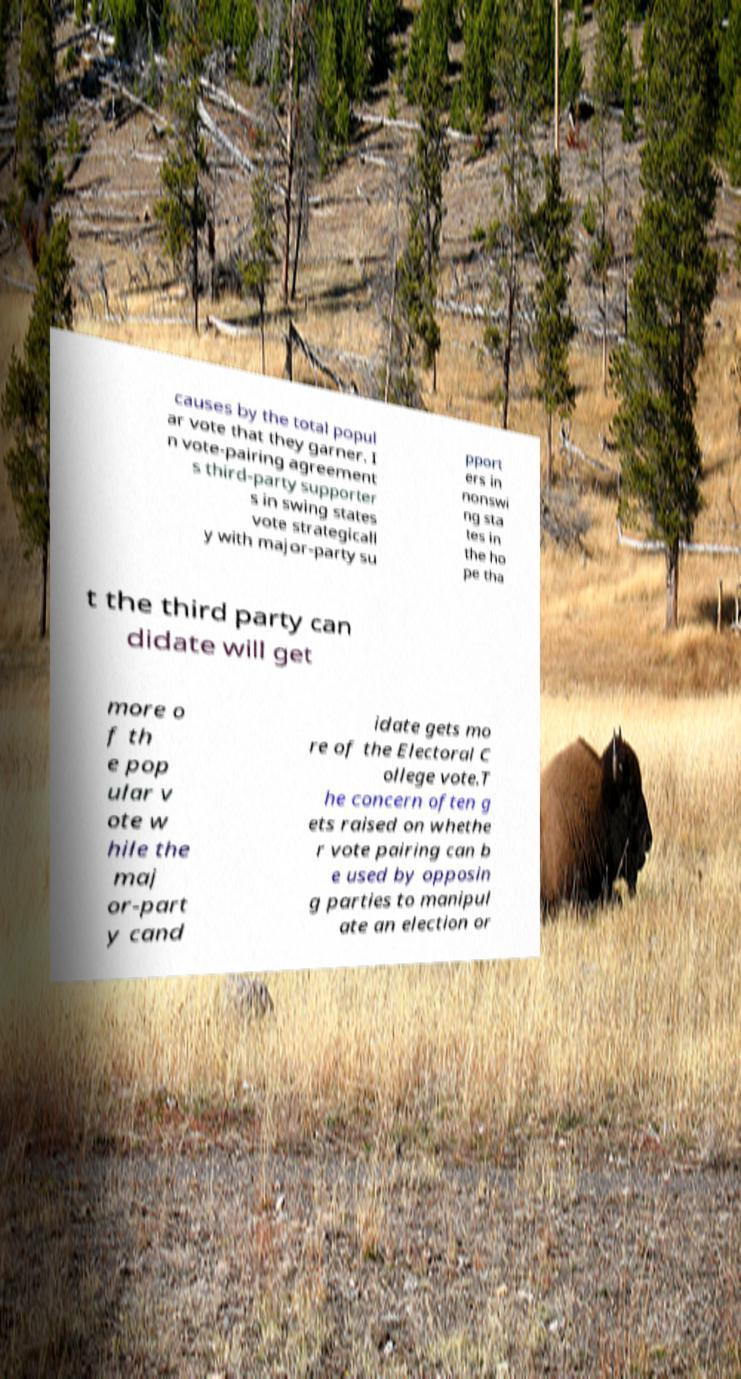I need the written content from this picture converted into text. Can you do that? causes by the total popul ar vote that they garner. I n vote-pairing agreement s third-party supporter s in swing states vote strategicall y with major-party su pport ers in nonswi ng sta tes in the ho pe tha t the third party can didate will get more o f th e pop ular v ote w hile the maj or-part y cand idate gets mo re of the Electoral C ollege vote.T he concern often g ets raised on whethe r vote pairing can b e used by opposin g parties to manipul ate an election or 